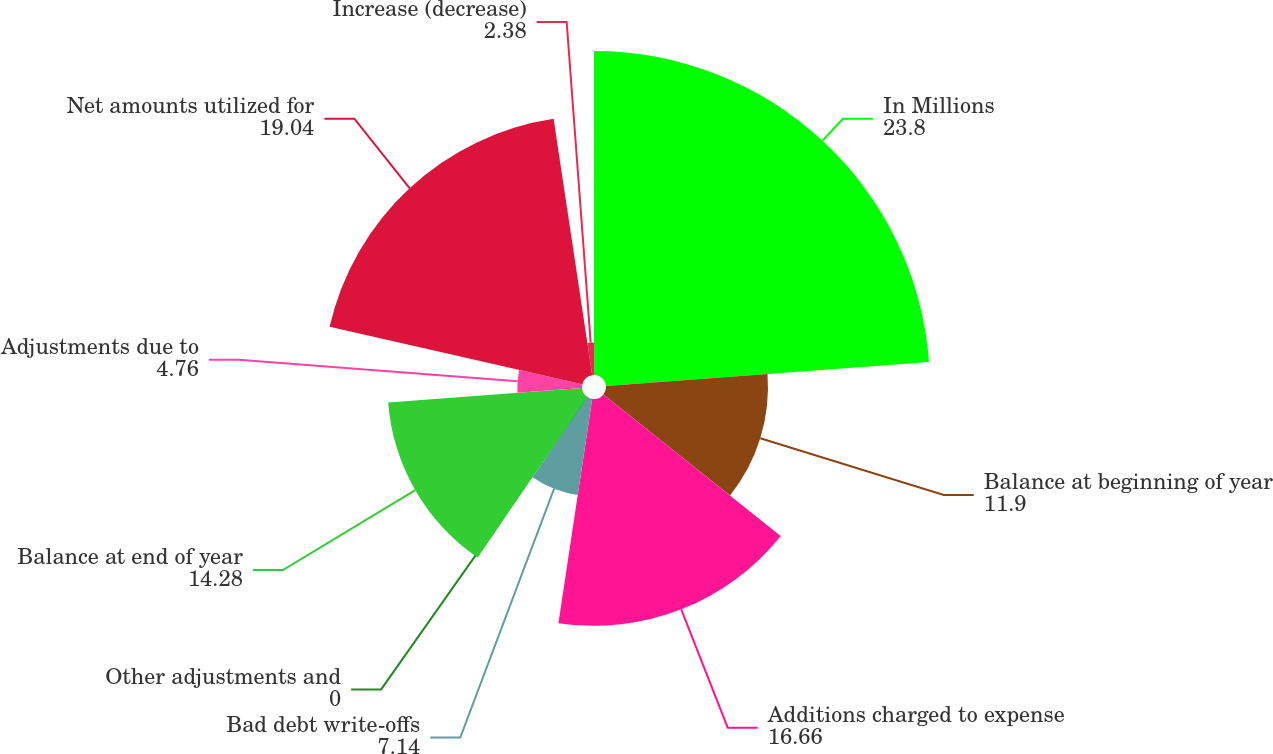Convert chart. <chart><loc_0><loc_0><loc_500><loc_500><pie_chart><fcel>In Millions<fcel>Balance at beginning of year<fcel>Additions charged to expense<fcel>Bad debt write-offs<fcel>Other adjustments and<fcel>Balance at end of year<fcel>Adjustments due to<fcel>Net amounts utilized for<fcel>Increase (decrease)<nl><fcel>23.8%<fcel>11.9%<fcel>16.66%<fcel>7.14%<fcel>0.0%<fcel>14.28%<fcel>4.76%<fcel>19.04%<fcel>2.38%<nl></chart> 